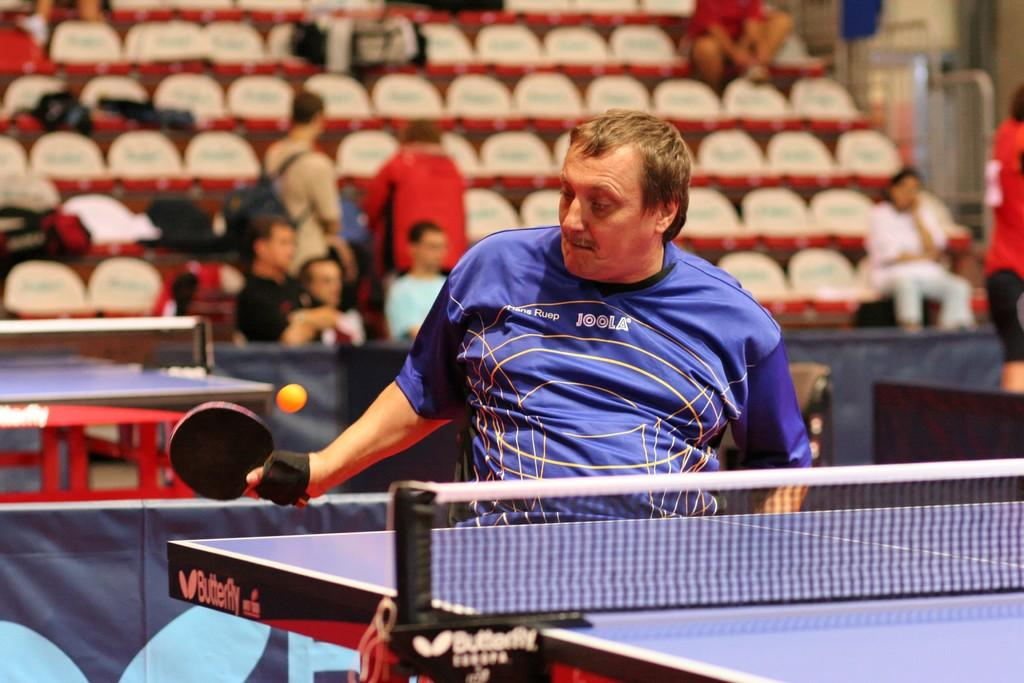Who is the main subject in the image? There is a man in the image. What is the man doing in the image? The man is playing with a bat. Are there any other people present in the image? Yes, there are people behind the man. What type of basket is the man using to catch the ball in the image? There is no basket present in the image, and the man is not shown catching a ball. 